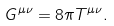Convert formula to latex. <formula><loc_0><loc_0><loc_500><loc_500>G ^ { \mu \nu } = 8 \pi T ^ { \mu \nu } .</formula> 